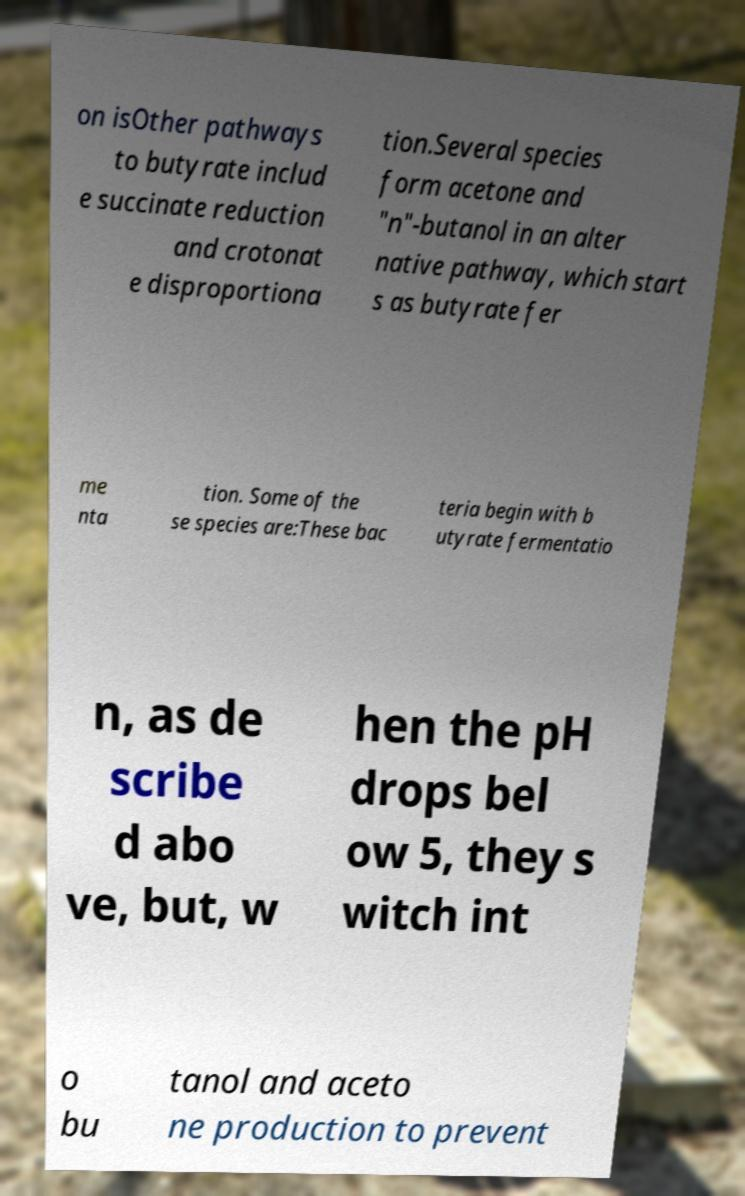Could you extract and type out the text from this image? on isOther pathways to butyrate includ e succinate reduction and crotonat e disproportiona tion.Several species form acetone and "n"-butanol in an alter native pathway, which start s as butyrate fer me nta tion. Some of the se species are:These bac teria begin with b utyrate fermentatio n, as de scribe d abo ve, but, w hen the pH drops bel ow 5, they s witch int o bu tanol and aceto ne production to prevent 